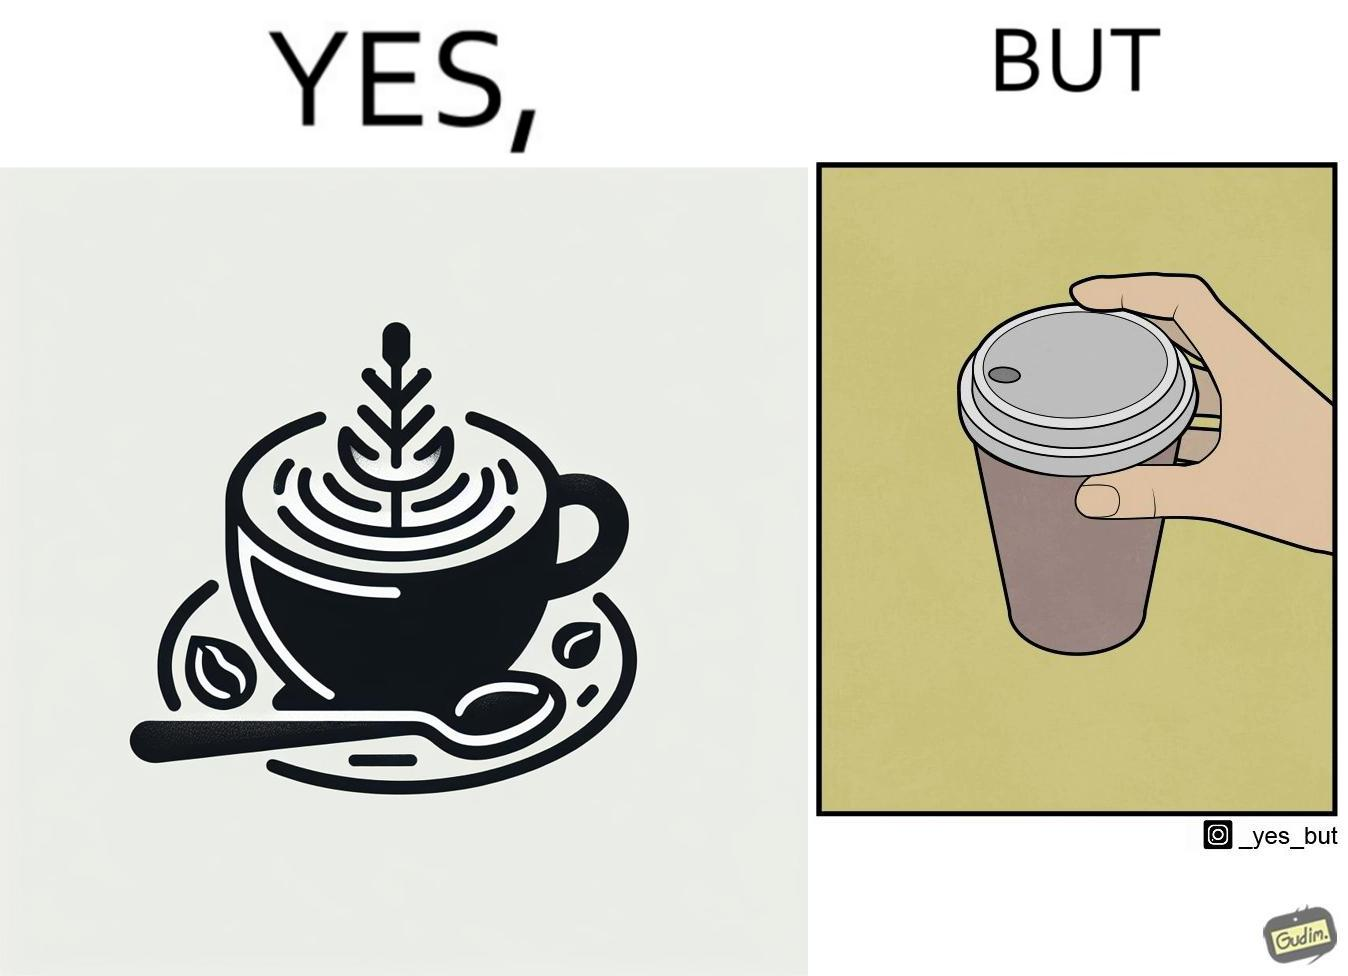Describe the contrast between the left and right parts of this image. In the left part of the image: It is a cup of coffee with latte art In the right part of the image: It is a cup of coffee with its lid on top 